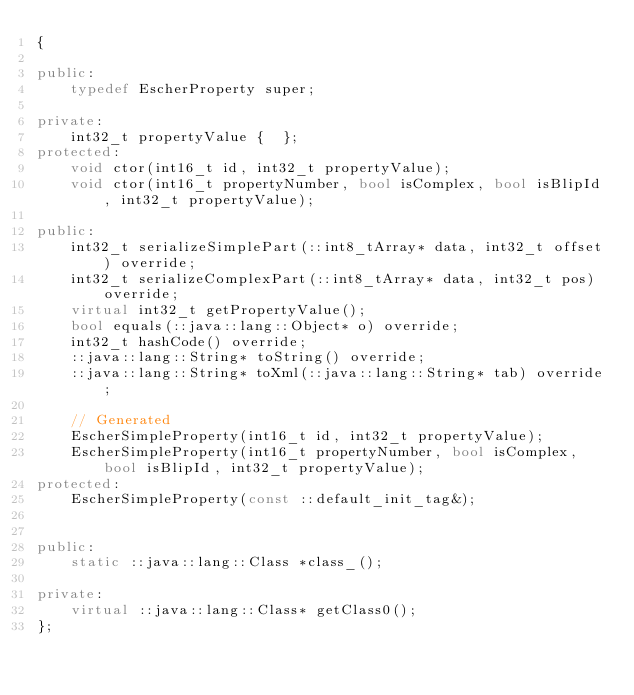<code> <loc_0><loc_0><loc_500><loc_500><_C++_>{

public:
    typedef EscherProperty super;

private:
    int32_t propertyValue {  };
protected:
    void ctor(int16_t id, int32_t propertyValue);
    void ctor(int16_t propertyNumber, bool isComplex, bool isBlipId, int32_t propertyValue);

public:
    int32_t serializeSimplePart(::int8_tArray* data, int32_t offset) override;
    int32_t serializeComplexPart(::int8_tArray* data, int32_t pos) override;
    virtual int32_t getPropertyValue();
    bool equals(::java::lang::Object* o) override;
    int32_t hashCode() override;
    ::java::lang::String* toString() override;
    ::java::lang::String* toXml(::java::lang::String* tab) override;

    // Generated
    EscherSimpleProperty(int16_t id, int32_t propertyValue);
    EscherSimpleProperty(int16_t propertyNumber, bool isComplex, bool isBlipId, int32_t propertyValue);
protected:
    EscherSimpleProperty(const ::default_init_tag&);


public:
    static ::java::lang::Class *class_();

private:
    virtual ::java::lang::Class* getClass0();
};
</code> 